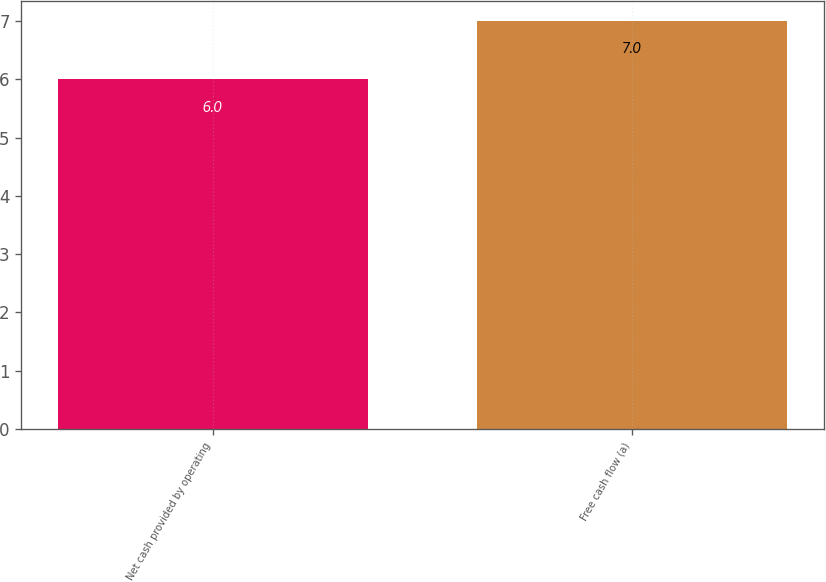Convert chart. <chart><loc_0><loc_0><loc_500><loc_500><bar_chart><fcel>Net cash provided by operating<fcel>Free cash flow (a)<nl><fcel>6<fcel>7<nl></chart> 